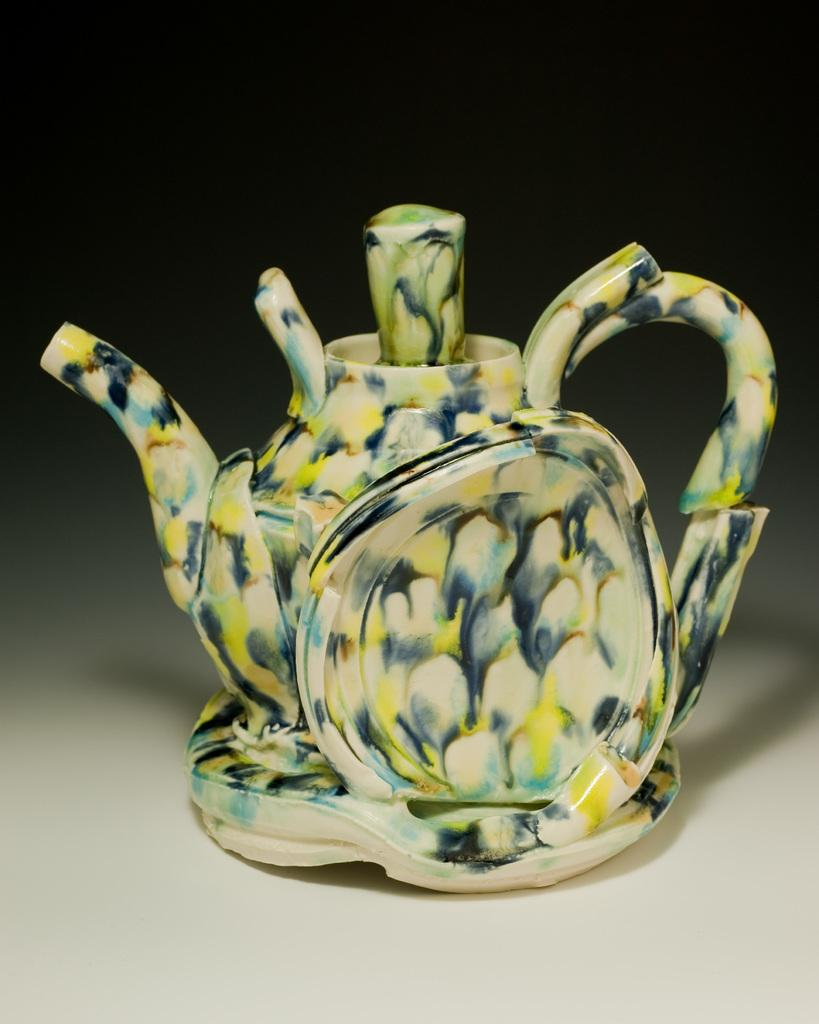What object is the main subject of the image? There is a kettle in the image. What can be observed about the background of the image? The background of the image is dark. What type of book is the crow reading in the image? There is no crow or book present in the image; it only features a kettle. What type of legal advice is the lawyer providing in the image? There is no lawyer or legal advice present in the image; it only features a kettle. 